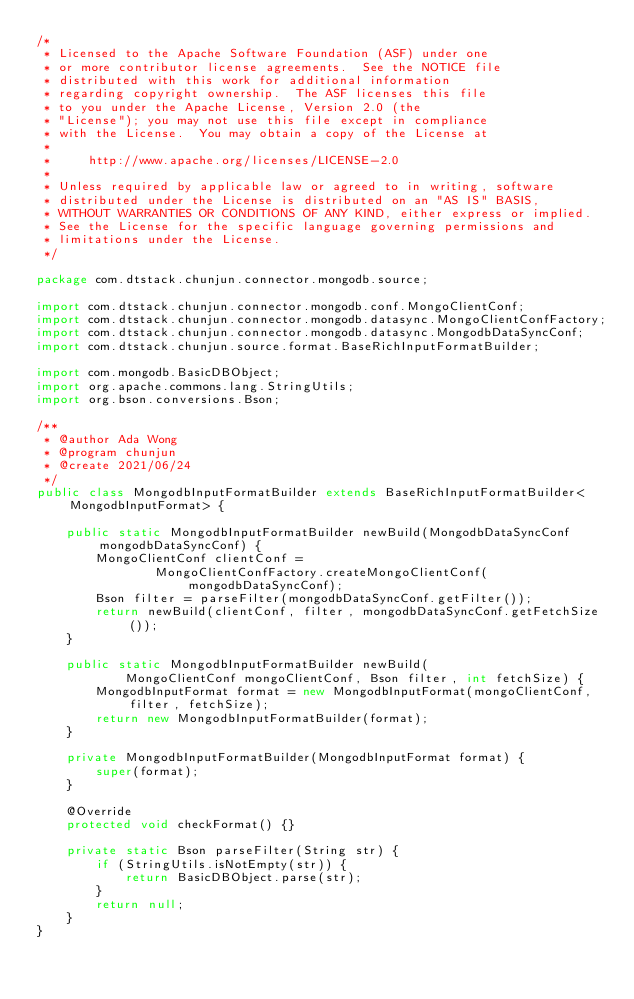<code> <loc_0><loc_0><loc_500><loc_500><_Java_>/*
 * Licensed to the Apache Software Foundation (ASF) under one
 * or more contributor license agreements.  See the NOTICE file
 * distributed with this work for additional information
 * regarding copyright ownership.  The ASF licenses this file
 * to you under the Apache License, Version 2.0 (the
 * "License"); you may not use this file except in compliance
 * with the License.  You may obtain a copy of the License at
 *
 *     http://www.apache.org/licenses/LICENSE-2.0
 *
 * Unless required by applicable law or agreed to in writing, software
 * distributed under the License is distributed on an "AS IS" BASIS,
 * WITHOUT WARRANTIES OR CONDITIONS OF ANY KIND, either express or implied.
 * See the License for the specific language governing permissions and
 * limitations under the License.
 */

package com.dtstack.chunjun.connector.mongodb.source;

import com.dtstack.chunjun.connector.mongodb.conf.MongoClientConf;
import com.dtstack.chunjun.connector.mongodb.datasync.MongoClientConfFactory;
import com.dtstack.chunjun.connector.mongodb.datasync.MongodbDataSyncConf;
import com.dtstack.chunjun.source.format.BaseRichInputFormatBuilder;

import com.mongodb.BasicDBObject;
import org.apache.commons.lang.StringUtils;
import org.bson.conversions.Bson;

/**
 * @author Ada Wong
 * @program chunjun
 * @create 2021/06/24
 */
public class MongodbInputFormatBuilder extends BaseRichInputFormatBuilder<MongodbInputFormat> {

    public static MongodbInputFormatBuilder newBuild(MongodbDataSyncConf mongodbDataSyncConf) {
        MongoClientConf clientConf =
                MongoClientConfFactory.createMongoClientConf(mongodbDataSyncConf);
        Bson filter = parseFilter(mongodbDataSyncConf.getFilter());
        return newBuild(clientConf, filter, mongodbDataSyncConf.getFetchSize());
    }

    public static MongodbInputFormatBuilder newBuild(
            MongoClientConf mongoClientConf, Bson filter, int fetchSize) {
        MongodbInputFormat format = new MongodbInputFormat(mongoClientConf, filter, fetchSize);
        return new MongodbInputFormatBuilder(format);
    }

    private MongodbInputFormatBuilder(MongodbInputFormat format) {
        super(format);
    }

    @Override
    protected void checkFormat() {}

    private static Bson parseFilter(String str) {
        if (StringUtils.isNotEmpty(str)) {
            return BasicDBObject.parse(str);
        }
        return null;
    }
}
</code> 